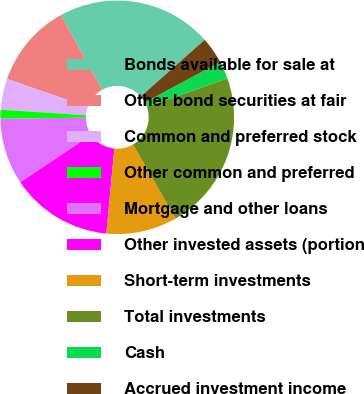Convert chart to OTSL. <chart><loc_0><loc_0><loc_500><loc_500><pie_chart><fcel>Bonds available for sale at<fcel>Other bond securities at fair<fcel>Common and preferred stock<fcel>Other common and preferred<fcel>Mortgage and other loans<fcel>Other invested assets (portion<fcel>Short-term investments<fcel>Total investments<fcel>Cash<fcel>Accrued investment income<nl><fcel>21.47%<fcel>11.66%<fcel>4.29%<fcel>1.23%<fcel>9.2%<fcel>14.11%<fcel>9.82%<fcel>22.09%<fcel>2.45%<fcel>3.68%<nl></chart> 